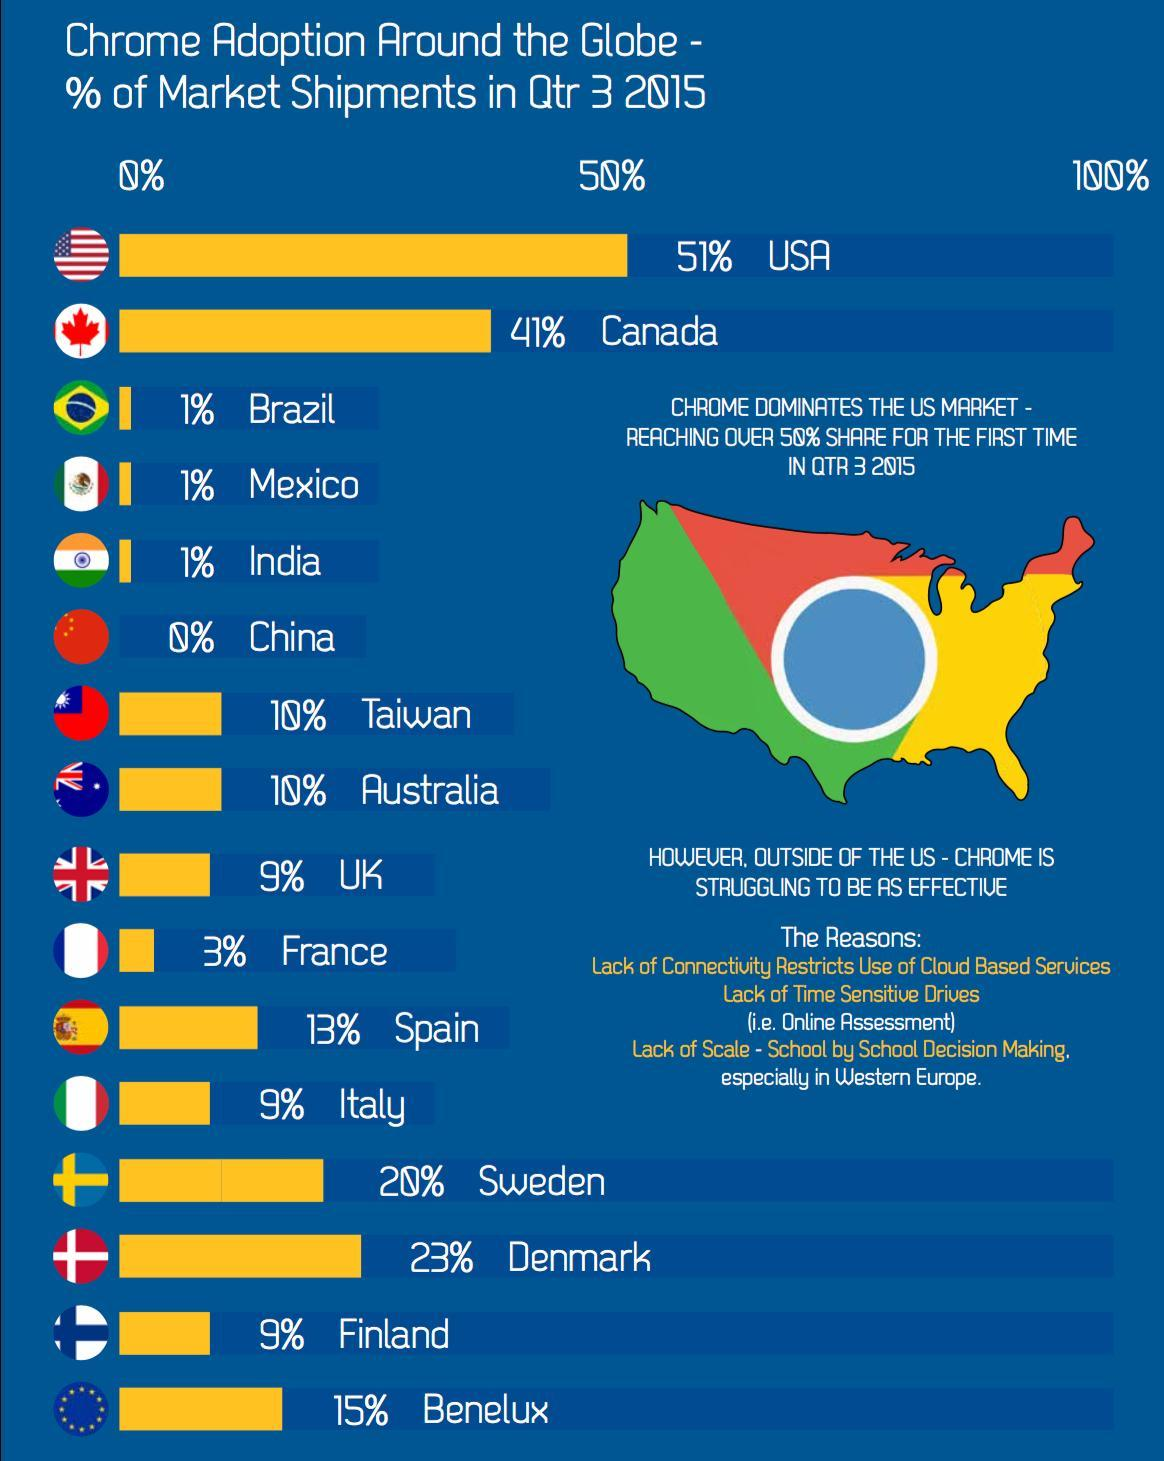What percentage of market shipments  in India were done through chrome in Qtr 3 2015?
Answer the question with a short phrase. 1% Which country shows least percentage of market shipments done through chrome in Qtr 3 2015? China Which country has the highest percentage of market shipments  done through chrome in Qtr 3 2015? USA Which country has the second highest percentage of market shipments done through chrome in Qtr 3 2015? Canada What percentage of market shipments in Spain were done through chrome in Qtr 3 2015? 13% What percentage of market shipments in Denmark were done through chrome in Qtr 3 2015? 23% 